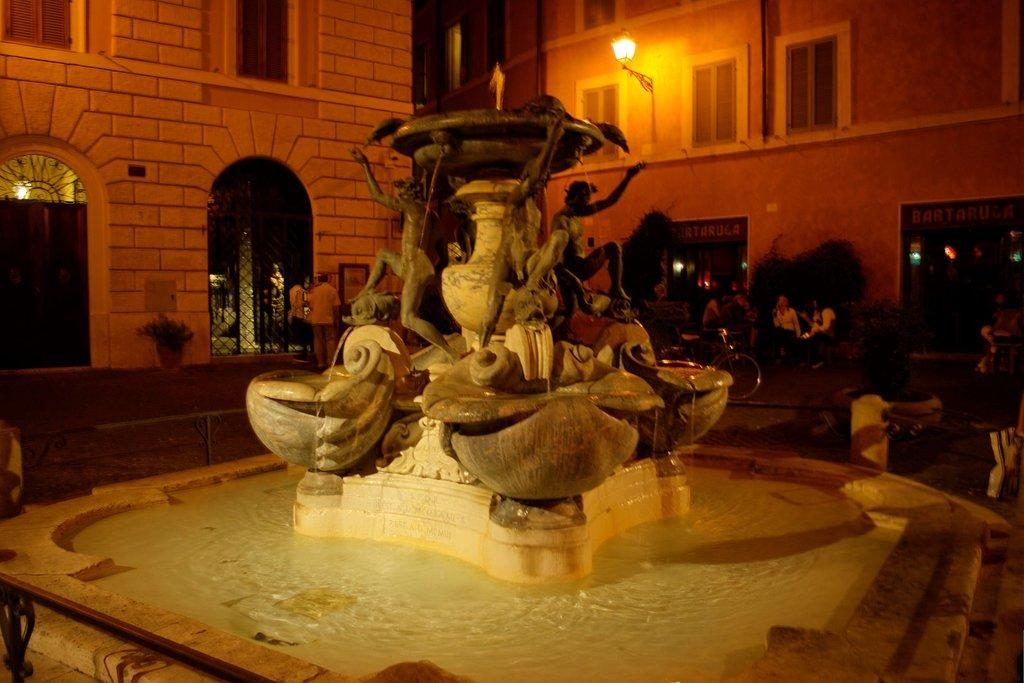What is the main feature in the image? There is a fountain in the image. Are there any people present in the image? Yes, there are people in the image. What else can be seen on the road in the image? There is a bicycle on the road in the image. What is attached to a building in the image? A light is attached to a building in the image. What type of natural elements are present in the image? There are trees in the image. What verse can be heard being recited by the cow in the image? There is no cow present in the image, and therefore no verse can be heard. What time of day is depicted in the image? The provided facts do not mention the time of day, so it cannot be determined from the image. 